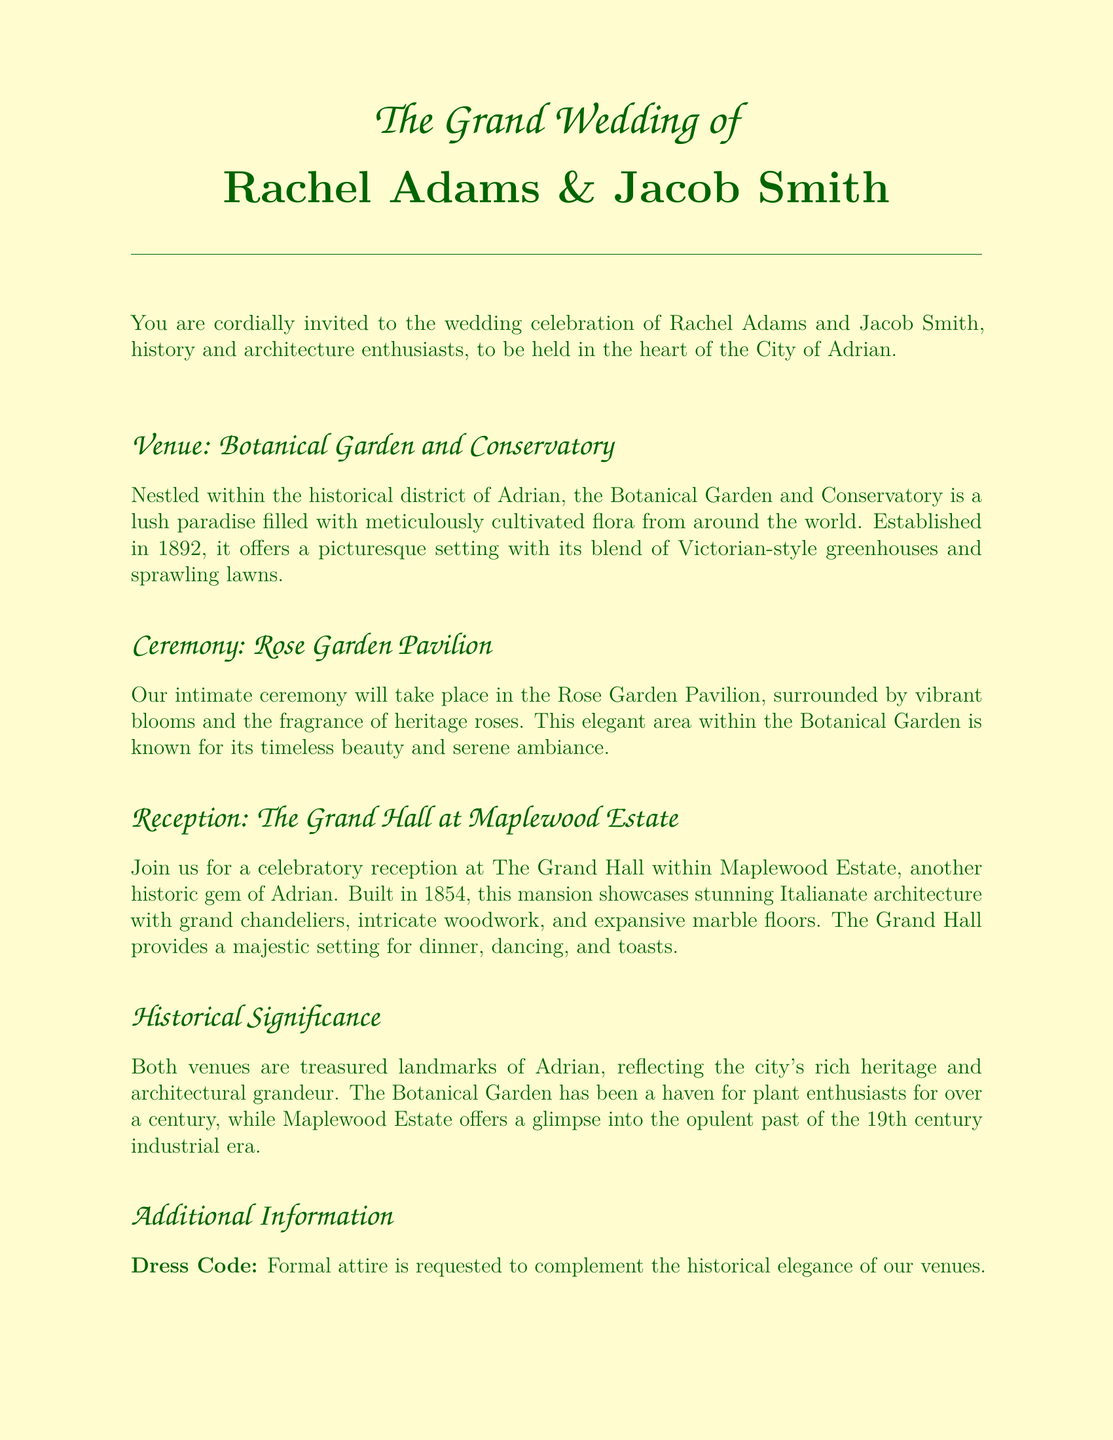What is the full name of the couple? The full names of the couple getting married are Rachel Adams and Jacob Smith, as stated at the beginning of the invitation.
Answer: Rachel Adams & Jacob Smith When was the Botanical Garden and Conservatory established? The date of establishment for the Botanical Garden and Conservatory is clearly mentioned in the text.
Answer: 1892 What is the dress code for the wedding? The invitation specifies the dress code in the additional information section.
Answer: Formal attire What type of architecture does the Grand Hall at Maplewood Estate showcase? The architectural style of the Grand Hall is explicitly described in the reception section.
Answer: Italianate What is the RSVP deadline? The invitation specifies the deadline for RSVPs in the additional information section.
Answer: October 1st In which garden will the ceremony take place? The location of the ceremony is mentioned in the ceremony section of the invitation.
Answer: Rose Garden Pavilion How far is The Historic Adrian Inn from the venues? The document indicates the proximity of The Historic Adrian Inn to the venues in the accommodations section.
Answer: A short distance What year was the Maplewood Estate built? The year of construction for Maplewood Estate is stated in the reception section.
Answer: 1854 